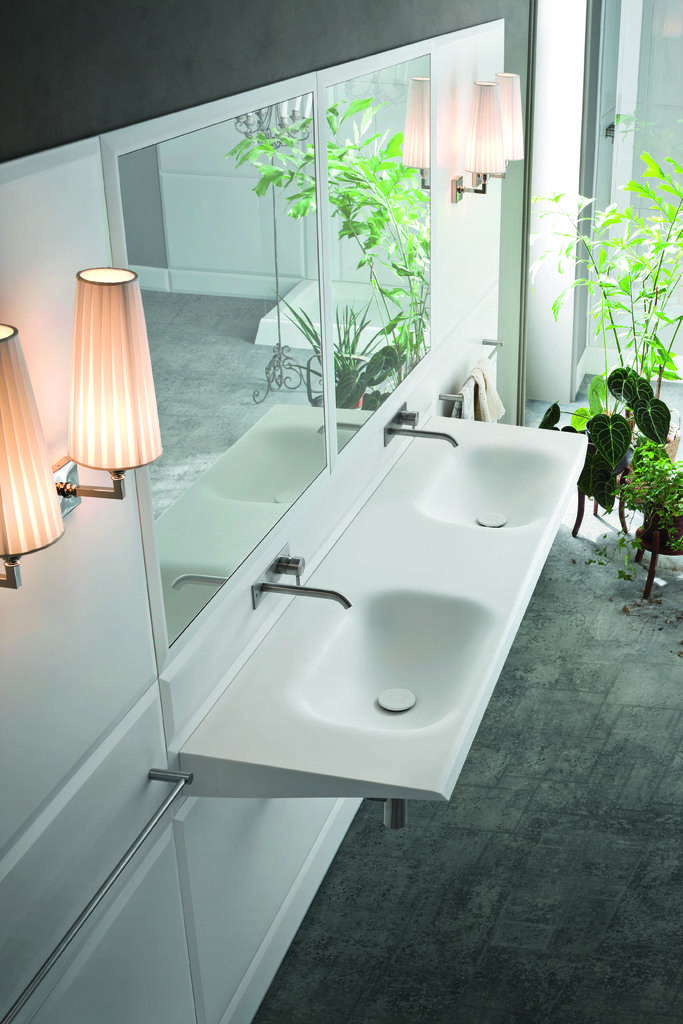What can be found in the image that is used for washing hands? There are sinks with taps in the image. What is present on a wall in the image that might be used for personal grooming? There are mirrors on a wall in the image. What is attached to the wall in the image that provides light? There are lamps on a wall in the image. What type of vegetation is present in the image? There are plants in pots in the image. What can be seen in the image that might be used for drying hands or body? There is a towel on a holder in the image. How many sheep are visible in the image? There are no sheep present in the image. What type of credit is being offered in the image? There is no credit being offered in the image. 